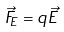<formula> <loc_0><loc_0><loc_500><loc_500>\vec { F } _ { E } = q \vec { E }</formula> 